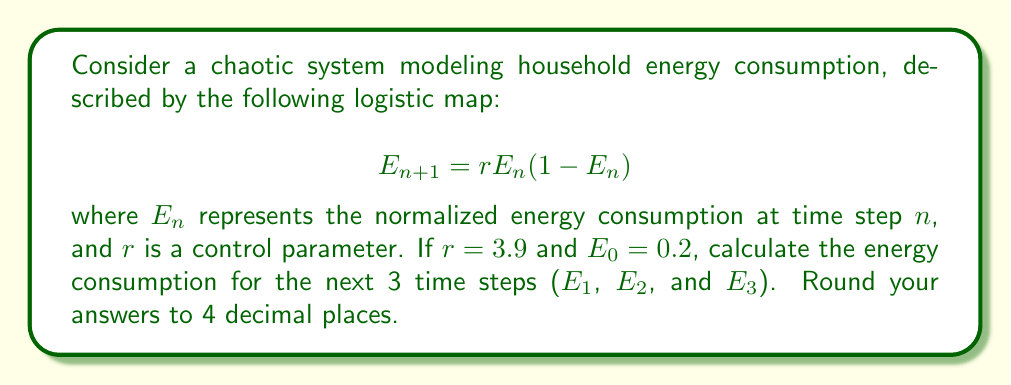Show me your answer to this math problem. To solve this problem, we'll use the given logistic map equation and initial conditions to calculate the energy consumption for each time step:

1. For $E_1$:
   $$E_1 = rE_0(1-E_0) = 3.9 \times 0.2 \times (1-0.2) = 3.9 \times 0.2 \times 0.8 = 0.624$$

2. For $E_2$:
   $$E_2 = rE_1(1-E_1) = 3.9 \times 0.624 \times (1-0.624) = 3.9 \times 0.624 \times 0.376 = 0.9165$$

3. For $E_3$:
   $$E_3 = rE_2(1-E_2) = 3.9 \times 0.9165 \times (1-0.9165) = 3.9 \times 0.9165 \times 0.0835 = 0.2990$$

Rounding each result to 4 decimal places:
$E_1 = 0.6240$
$E_2 = 0.9165$
$E_3 = 0.2990$
Answer: $E_1 = 0.6240$, $E_2 = 0.9165$, $E_3 = 0.2990$ 